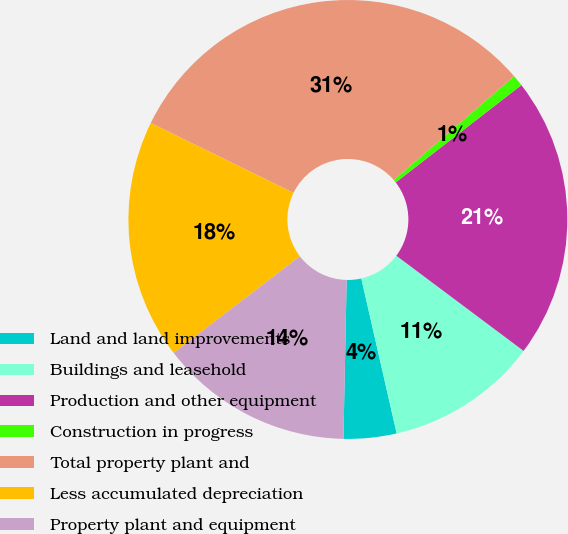Convert chart to OTSL. <chart><loc_0><loc_0><loc_500><loc_500><pie_chart><fcel>Land and land improvements<fcel>Buildings and leasehold<fcel>Production and other equipment<fcel>Construction in progress<fcel>Total property plant and<fcel>Less accumulated depreciation<fcel>Property plant and equipment<nl><fcel>3.89%<fcel>11.21%<fcel>20.71%<fcel>0.83%<fcel>31.44%<fcel>17.65%<fcel>14.27%<nl></chart> 